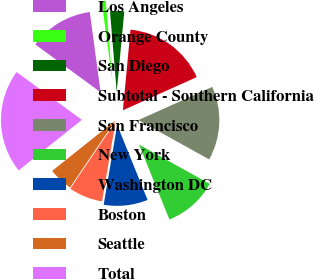Convert chart. <chart><loc_0><loc_0><loc_500><loc_500><pie_chart><fcel>Los Angeles<fcel>Orange County<fcel>San Diego<fcel>Subtotal - Southern California<fcel>San Francisco<fcel>New York<fcel>Washington DC<fcel>Boston<fcel>Seattle<fcel>Total<nl><fcel>12.8%<fcel>0.81%<fcel>2.81%<fcel>16.79%<fcel>14.79%<fcel>10.8%<fcel>8.8%<fcel>6.8%<fcel>4.81%<fcel>20.79%<nl></chart> 